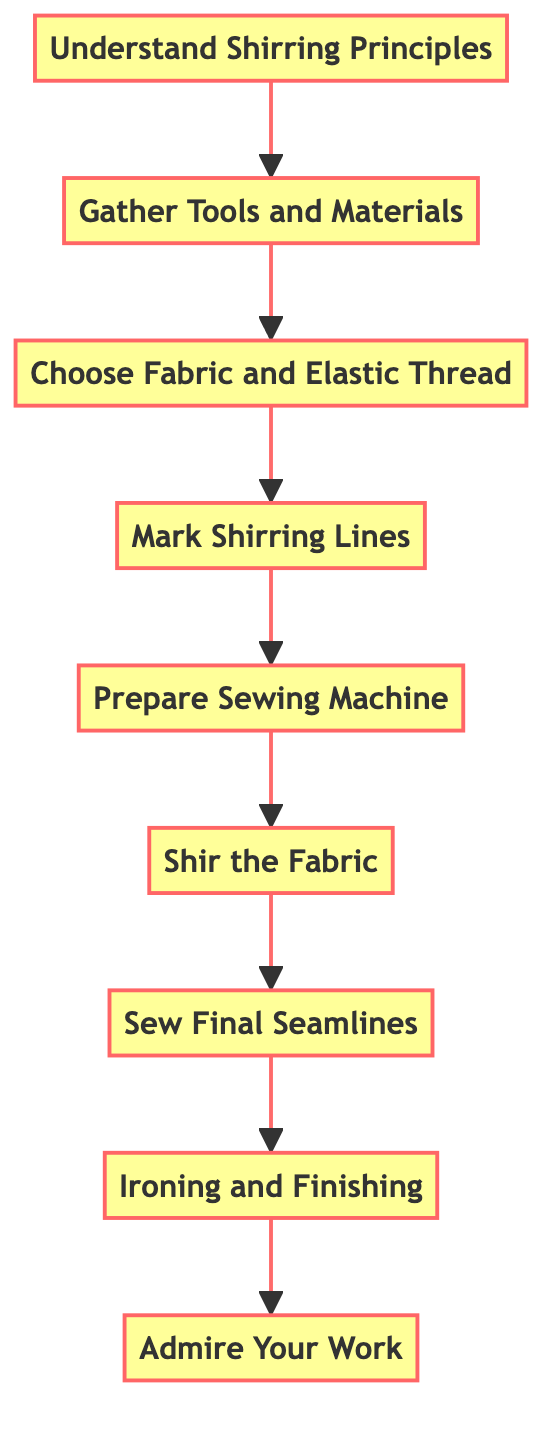What is the first step in the diagram? The first step is located at the bottom of the flowchart. It starts with "Understand Shirring Principles."
Answer: Understand Shirring Principles How many steps are there in total? By counting the nodes in the flowchart, there are 9 steps listed in the process of achieving perfect shirring.
Answer: 9 What step comes before "Sew Final Seamlines"? Looking at the sequence, "Shir the Fabric" directly precedes "Sew Final Seamlines."
Answer: Shir the Fabric Which step involves using elastic thread? The step titled "Prepare Sewing Machine" indicates that the bobbin should be replaced with elastic thread, explaining its importance in the process.
Answer: Prepare Sewing Machine What is the last step in achieving perfect shirring? The last step, found at the top of the flowchart, is "Admire Your Work," which is focused on reviewing the finished piece.
Answer: Admire Your Work Which step requires marking lines on the fabric? The step "Mark Shirring Lines" specifically instructs to use fabric chalk or a marking pen to draw parallel lines where the fabric will be shirred.
Answer: Mark Shirring Lines What two steps come after "Choose Fabric and Elastic Thread"? After "Choose Fabric and Elastic Thread," the next two steps sequentially are "Mark Shirring Lines" and "Prepare Sewing Machine."
Answer: Mark Shirring Lines, Prepare Sewing Machine Explain the relationship between "Ironing and Finishing" and "Sew Final Seamlines." "Ironing and Finishing" comes after "Sew Final Seamlines," indicating that ironing helps set the stitches after all seam lines are completed. This suggests a finalization process where the integrity of the shirring is maintained by proper finishing.
Answer: Ironing and Finishing follows Sew Final Seamlines What is the purpose of understanding shirring principles? The purpose is to learn how shirring operates using elastic thread on the bobbin, which is essential before beginning the manipulation of fabric for shirring.
Answer: Learn about shirring operations 